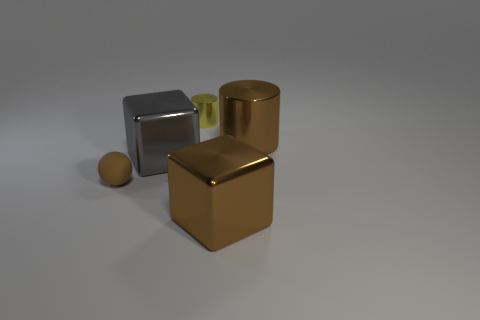Is there anything else that has the same material as the small brown ball?
Provide a short and direct response. No. Are there any tiny yellow cylinders that have the same material as the brown block?
Ensure brevity in your answer.  Yes. What is the shape of the large gray metallic thing?
Offer a terse response. Cube. Is the size of the gray metal thing the same as the brown metallic cylinder?
Provide a succinct answer. Yes. What number of other objects are there of the same shape as the brown matte thing?
Your response must be concise. 0. What shape is the tiny object behind the gray object?
Your answer should be compact. Cylinder. Is the shape of the small rubber object left of the yellow shiny object the same as the brown metallic object behind the brown matte sphere?
Your response must be concise. No. Are there an equal number of gray shiny blocks that are behind the tiny yellow thing and blue balls?
Offer a terse response. Yes. There is a brown object that is the same shape as the small yellow metal thing; what material is it?
Keep it short and to the point. Metal. What is the shape of the large object that is behind the big cube behind the small brown matte ball?
Keep it short and to the point. Cylinder. 